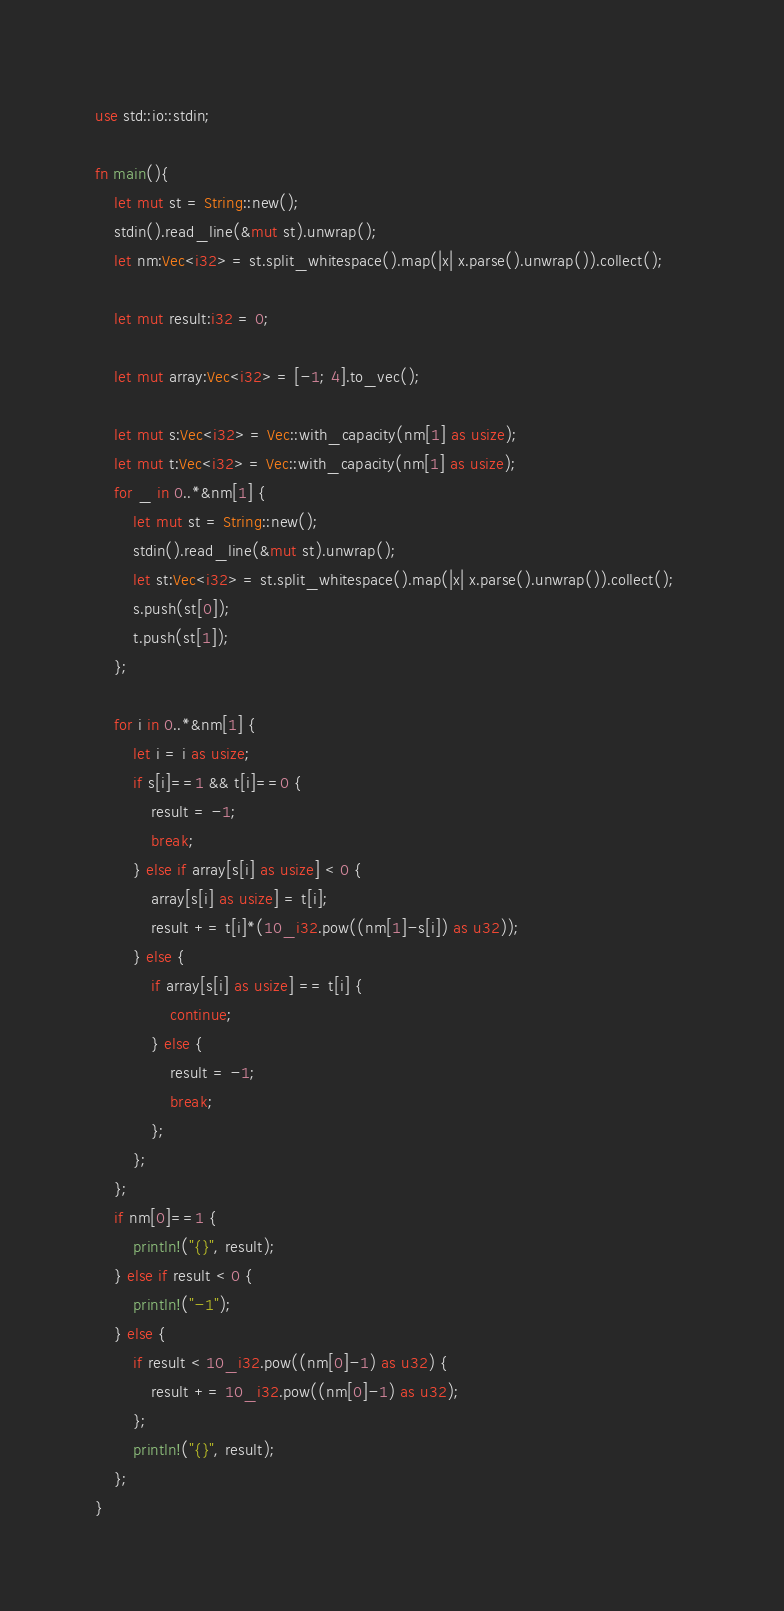Convert code to text. <code><loc_0><loc_0><loc_500><loc_500><_Rust_>use std::io::stdin;

fn main(){
    let mut st = String::new();
    stdin().read_line(&mut st).unwrap();
    let nm:Vec<i32> = st.split_whitespace().map(|x| x.parse().unwrap()).collect();

    let mut result:i32 = 0;

    let mut array:Vec<i32> = [-1; 4].to_vec();

    let mut s:Vec<i32> = Vec::with_capacity(nm[1] as usize);
    let mut t:Vec<i32> = Vec::with_capacity(nm[1] as usize);
    for _ in 0..*&nm[1] {
        let mut st = String::new();
        stdin().read_line(&mut st).unwrap();
        let st:Vec<i32> = st.split_whitespace().map(|x| x.parse().unwrap()).collect();   
        s.push(st[0]);
        t.push(st[1]);    
    };

    for i in 0..*&nm[1] {
        let i = i as usize;
        if s[i]==1 && t[i]==0 {
            result = -1;
            break;
        } else if array[s[i] as usize] < 0 {
            array[s[i] as usize] = t[i];
            result += t[i]*(10_i32.pow((nm[1]-s[i]) as u32));
        } else {
            if array[s[i] as usize] == t[i] {
                continue;
            } else {
                result = -1;
                break;
            };
        };
    };
    if nm[0]==1 {
        println!("{}", result);
    } else if result < 0 {
        println!("-1");
    } else {
        if result < 10_i32.pow((nm[0]-1) as u32) {
            result += 10_i32.pow((nm[0]-1) as u32);
        };
        println!("{}", result);
    };
}</code> 